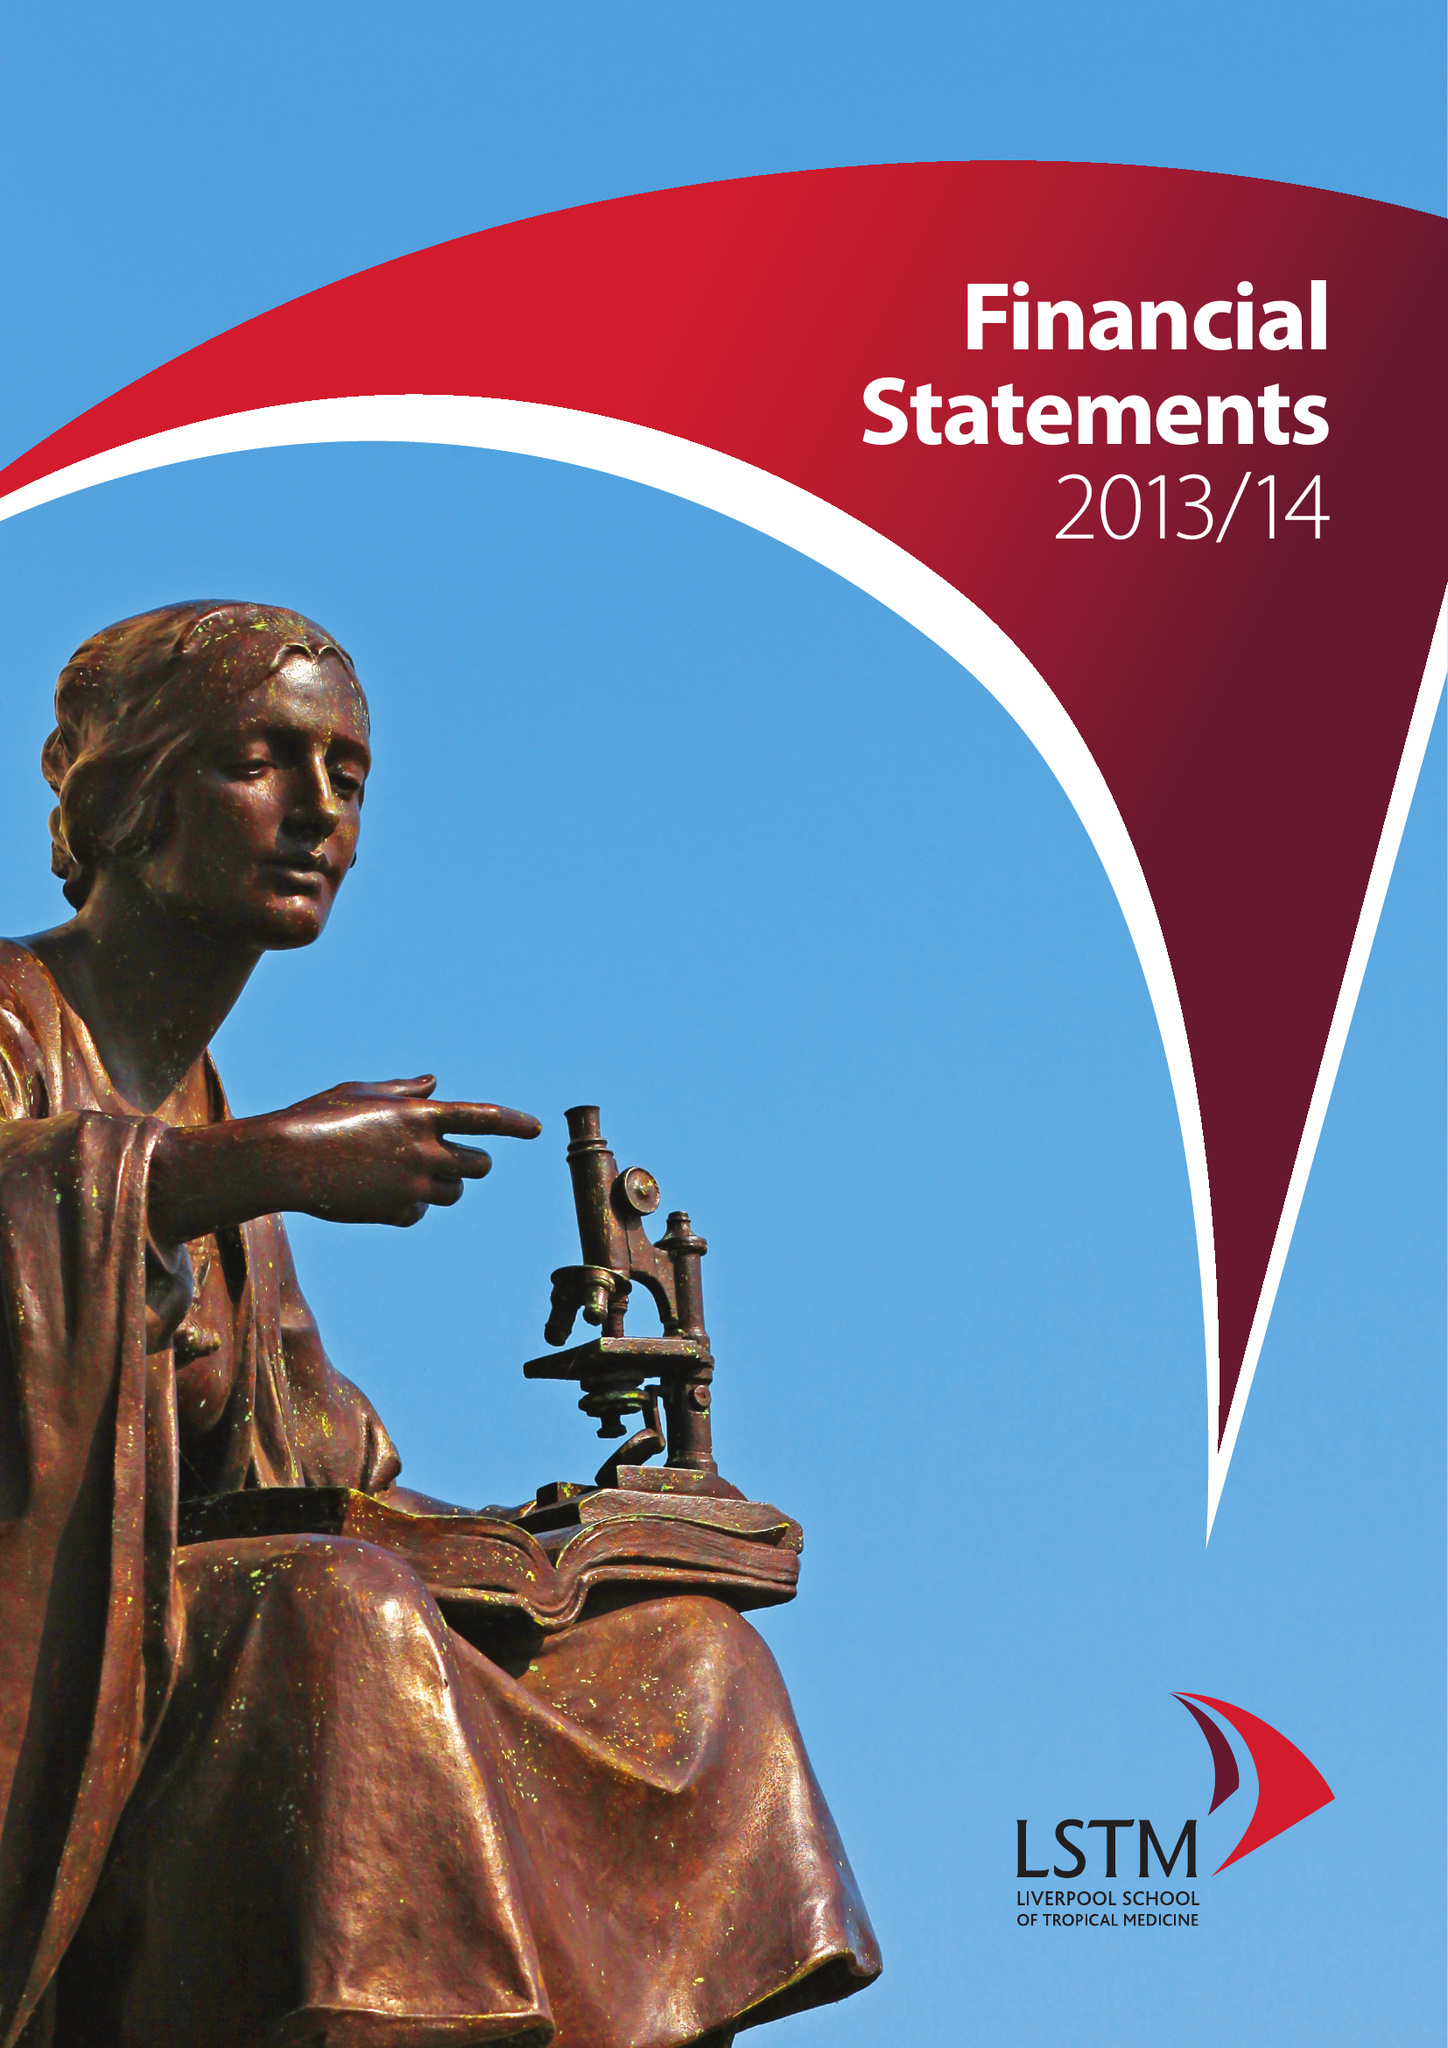What is the value for the income_annually_in_british_pounds?
Answer the question using a single word or phrase. 65390000.00 